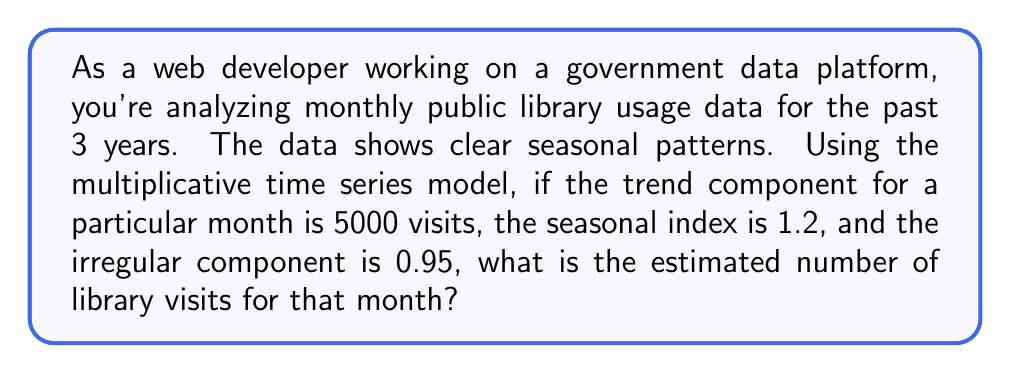Could you help me with this problem? To solve this problem, we need to understand the components of a multiplicative time series model and how they interact. The multiplicative model is given by:

$$Y_t = T_t \times S_t \times I_t$$

Where:
$Y_t$ = The actual value at time t
$T_t$ = The trend component at time t
$S_t$ = The seasonal component at time t
$I_t$ = The irregular component at time t

In this case, we are given:
$T_t = 5000$ (trend component)
$S_t = 1.2$ (seasonal index)
$I_t = 0.95$ (irregular component)

To find the estimated number of library visits, we simply multiply these components:

$$Y_t = 5000 \times 1.2 \times 0.95$$

$$Y_t = 6000 \times 0.95$$

$$Y_t = 5700$$

Therefore, the estimated number of library visits for that month is 5700.

This multiplicative model is particularly useful for seasonal data where the magnitude of the seasonal fluctuations increases with the level of the series, which is often the case with public service usage data.
Answer: 5700 library visits 